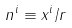<formula> <loc_0><loc_0><loc_500><loc_500>n ^ { i } \equiv x ^ { i } / r</formula> 